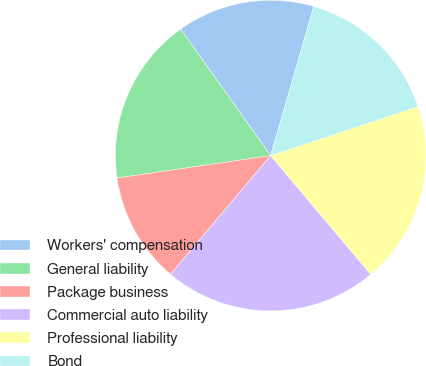<chart> <loc_0><loc_0><loc_500><loc_500><pie_chart><fcel>Workers' compensation<fcel>General liability<fcel>Package business<fcel>Commercial auto liability<fcel>Professional liability<fcel>Bond<nl><fcel>14.33%<fcel>17.46%<fcel>11.53%<fcel>22.31%<fcel>18.97%<fcel>15.41%<nl></chart> 